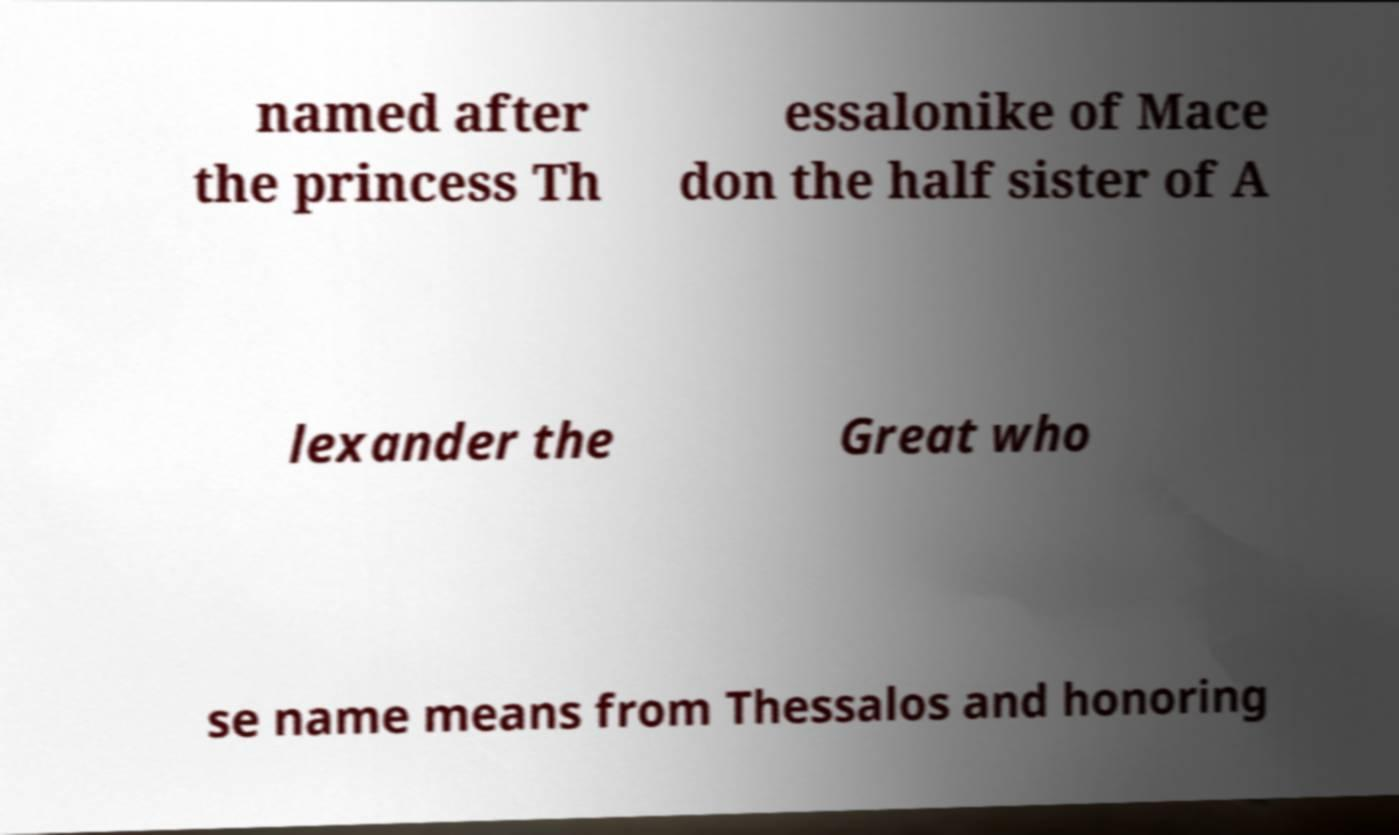I need the written content from this picture converted into text. Can you do that? named after the princess Th essalonike of Mace don the half sister of A lexander the Great who se name means from Thessalos and honoring 